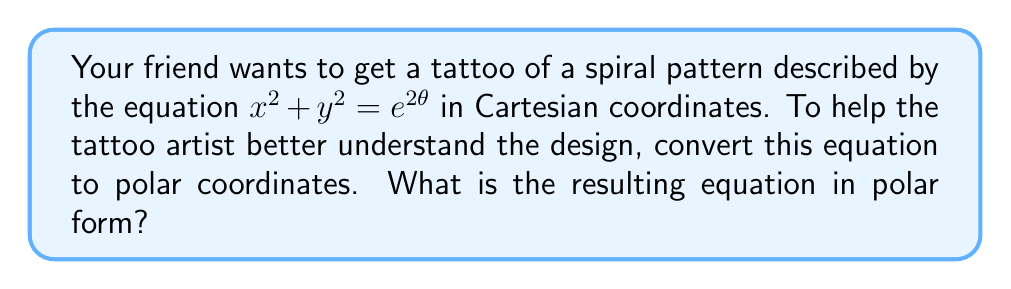Provide a solution to this math problem. To convert the given equation from Cartesian to polar coordinates, we'll follow these steps:

1) Recall the fundamental relationships between Cartesian $(x,y)$ and polar $(r,\theta)$ coordinates:
   $x = r \cos(\theta)$
   $y = r \sin(\theta)$

2) We also know that $x^2 + y^2 = r^2$ in polar coordinates.

3) The given equation is $x^2 + y^2 = e^{2\theta}$

4) Substituting $r^2$ for $x^2 + y^2$, we get:
   $r^2 = e^{2\theta}$

5) To simplify further, we can take the square root of both sides:
   $r = e^\theta$

This final equation, $r = e^\theta$, describes the same spiral pattern in polar coordinates. It's known as a logarithmic spiral or equiangular spiral.

In this form, it's easier for the tattoo artist to understand how the radius $r$ changes with respect to the angle $\theta$, which can be helpful in creating the tattoo design.
Answer: $r = e^\theta$ 